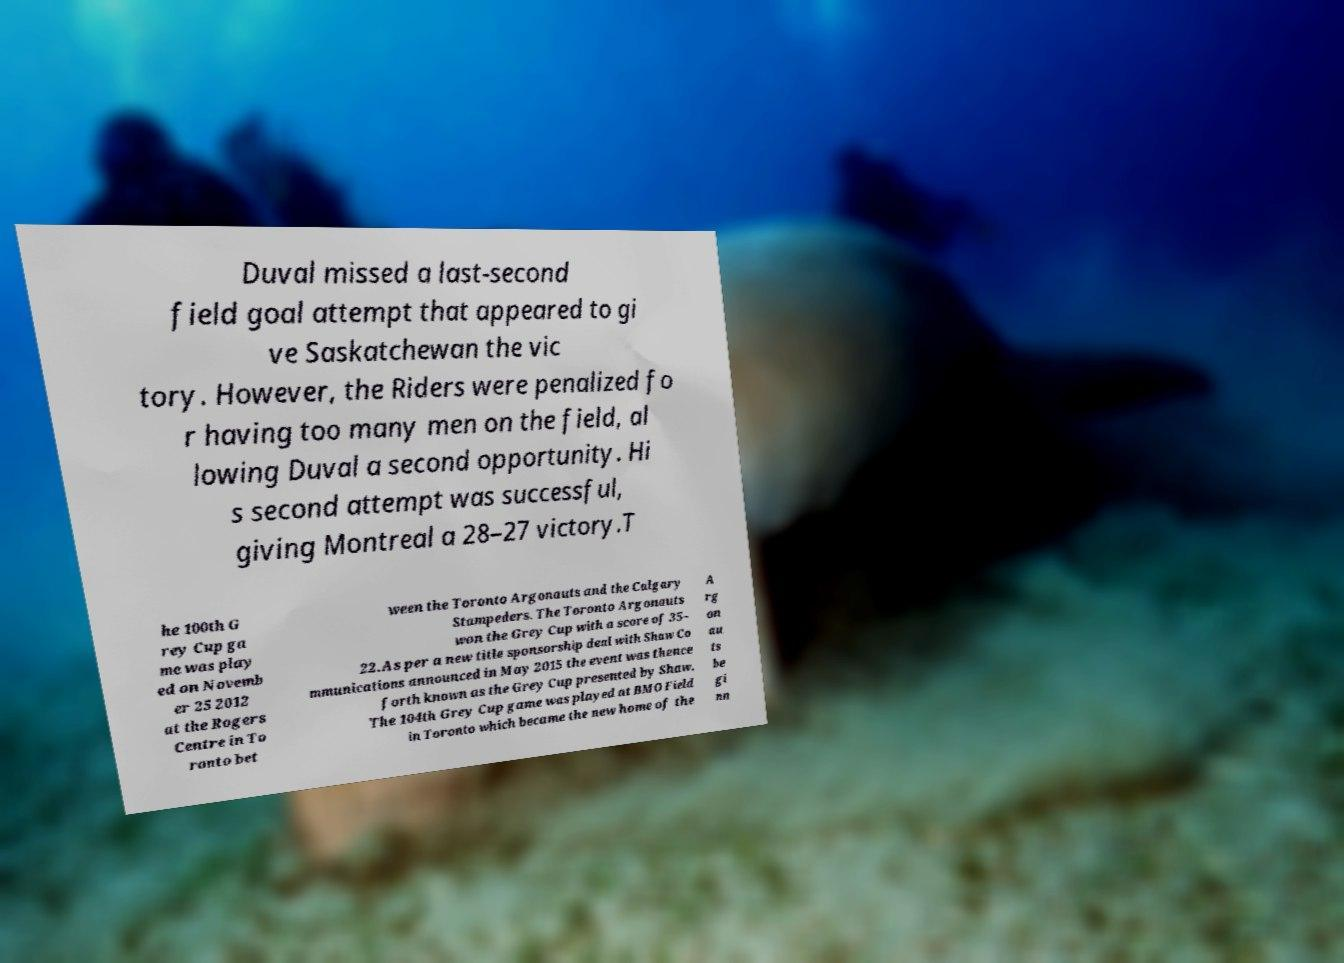Could you extract and type out the text from this image? Duval missed a last-second field goal attempt that appeared to gi ve Saskatchewan the vic tory. However, the Riders were penalized fo r having too many men on the field, al lowing Duval a second opportunity. Hi s second attempt was successful, giving Montreal a 28–27 victory.T he 100th G rey Cup ga me was play ed on Novemb er 25 2012 at the Rogers Centre in To ronto bet ween the Toronto Argonauts and the Calgary Stampeders. The Toronto Argonauts won the Grey Cup with a score of 35– 22.As per a new title sponsorship deal with Shaw Co mmunications announced in May 2015 the event was thence forth known as the Grey Cup presented by Shaw. The 104th Grey Cup game was played at BMO Field in Toronto which became the new home of the A rg on au ts be gi nn 